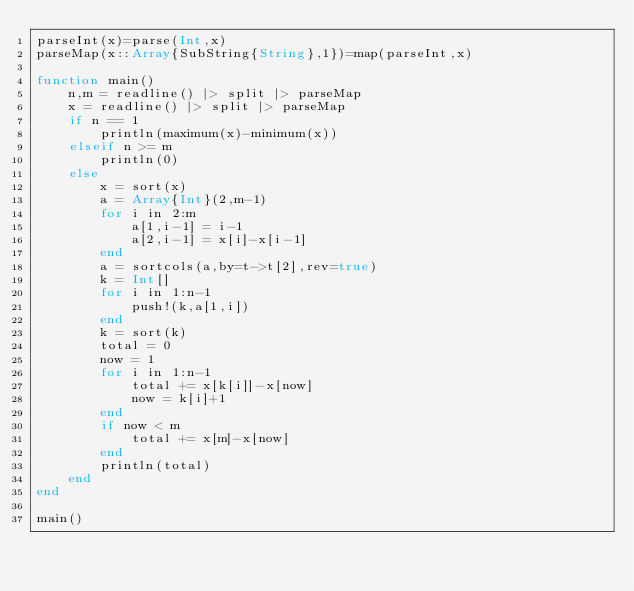<code> <loc_0><loc_0><loc_500><loc_500><_Julia_>parseInt(x)=parse(Int,x)
parseMap(x::Array{SubString{String},1})=map(parseInt,x)

function main()
	n,m = readline() |> split |> parseMap
	x = readline() |> split |> parseMap
	if n == 1
		println(maximum(x)-minimum(x))
	elseif n >= m
		println(0)
	else
		x = sort(x)
		a = Array{Int}(2,m-1)
		for i in 2:m
			a[1,i-1] = i-1
			a[2,i-1] = x[i]-x[i-1]
		end
		a = sortcols(a,by=t->t[2],rev=true)
		k = Int[]
		for i in 1:n-1
			push!(k,a[1,i])
		end
		k = sort(k)
		total = 0
		now = 1
		for i in 1:n-1
			total += x[k[i]]-x[now]
			now = k[i]+1
		end
		if now < m
			total += x[m]-x[now]
		end
		println(total)
	end
end
 
main()</code> 